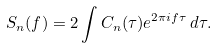Convert formula to latex. <formula><loc_0><loc_0><loc_500><loc_500>S _ { n } ( f ) = 2 \int C _ { n } ( \tau ) e ^ { 2 \pi i f \tau } \, d \tau .</formula> 